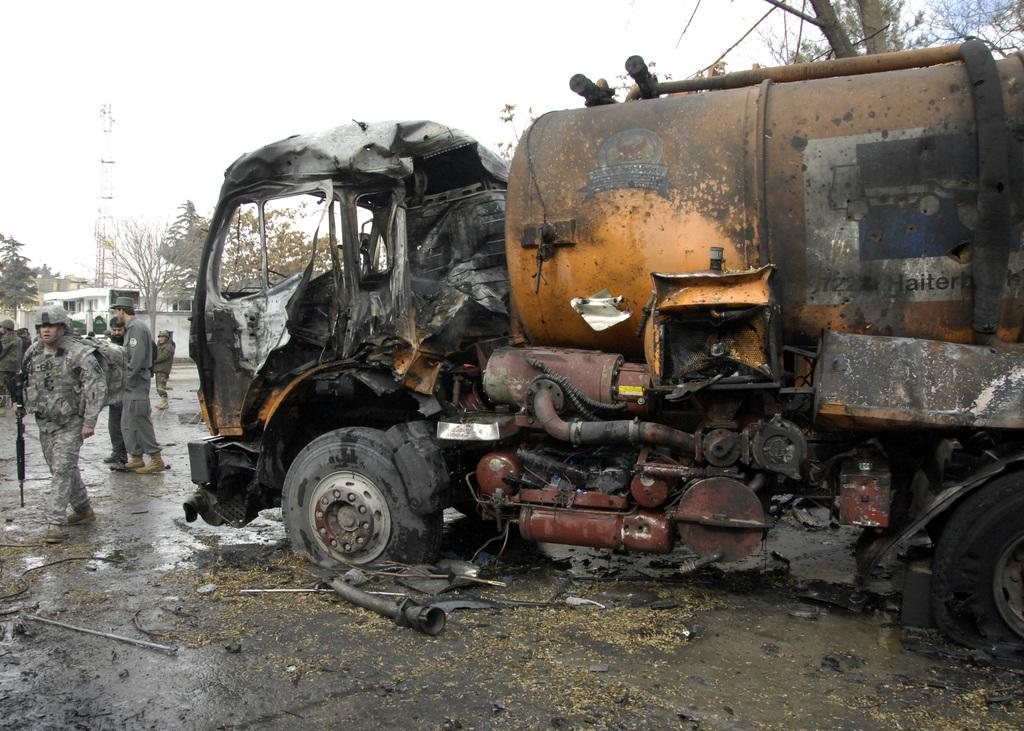What is the condition of the vehicle in the image? The vehicle in the image is damaged. What are the people in the image doing? There are groups of people standing in the image. What type of structure can be seen in the image? There is a building in the image. What type of vegetation is present in the image? There are trees in the image. What tall structure can be seen in the image? There is a tower in the image. What color is the bead hanging from the tower in the image? There is no bead hanging from the tower in the image. What shape is the hook used by the people in the image? There is no hook being used by the people in the image. 